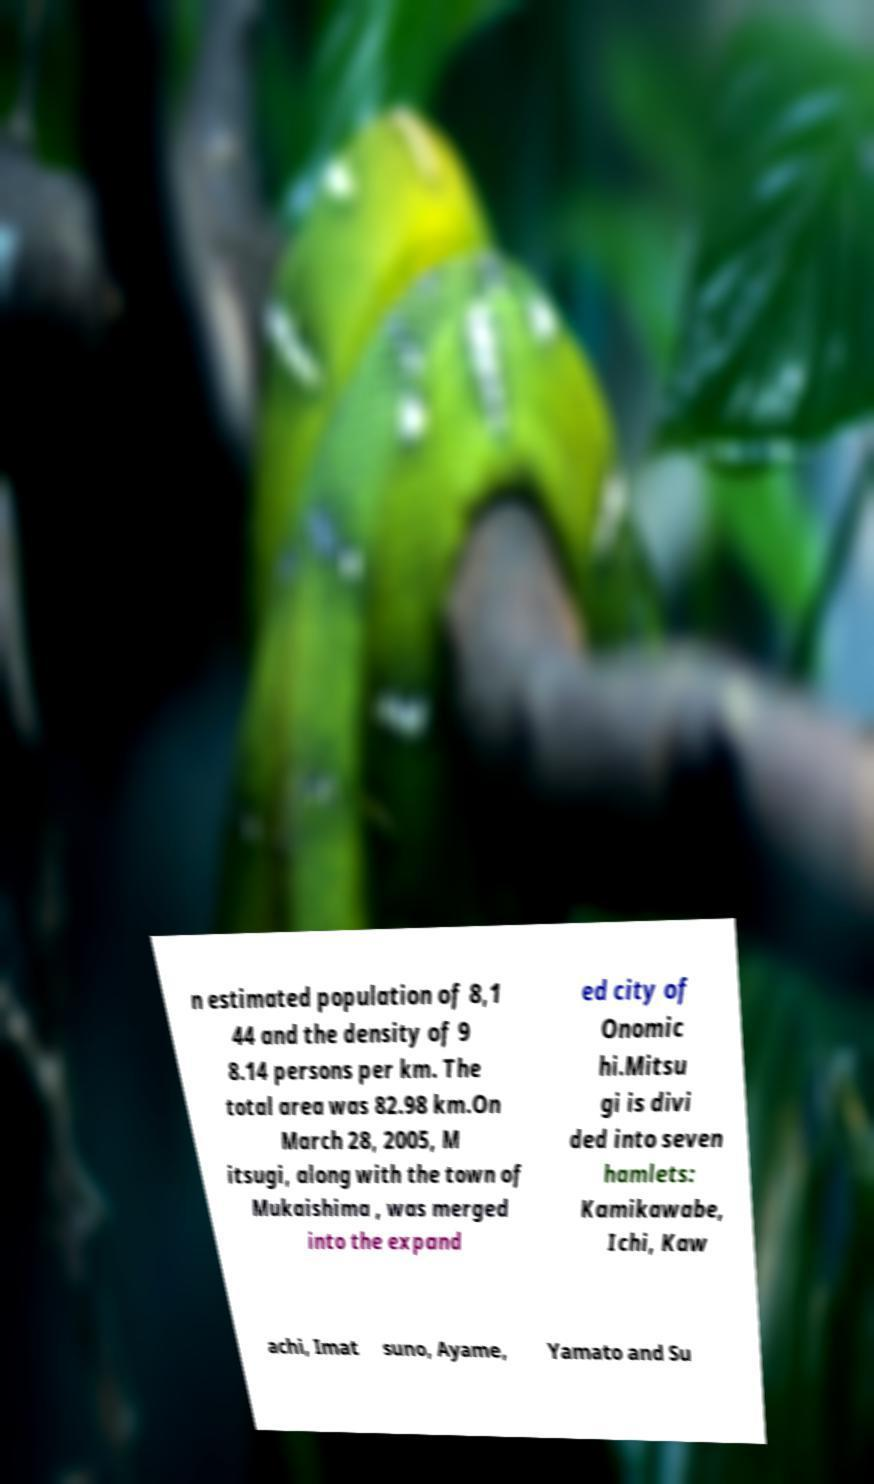Can you read and provide the text displayed in the image?This photo seems to have some interesting text. Can you extract and type it out for me? n estimated population of 8,1 44 and the density of 9 8.14 persons per km. The total area was 82.98 km.On March 28, 2005, M itsugi, along with the town of Mukaishima , was merged into the expand ed city of Onomic hi.Mitsu gi is divi ded into seven hamlets: Kamikawabe, Ichi, Kaw achi, Imat suno, Ayame, Yamato and Su 